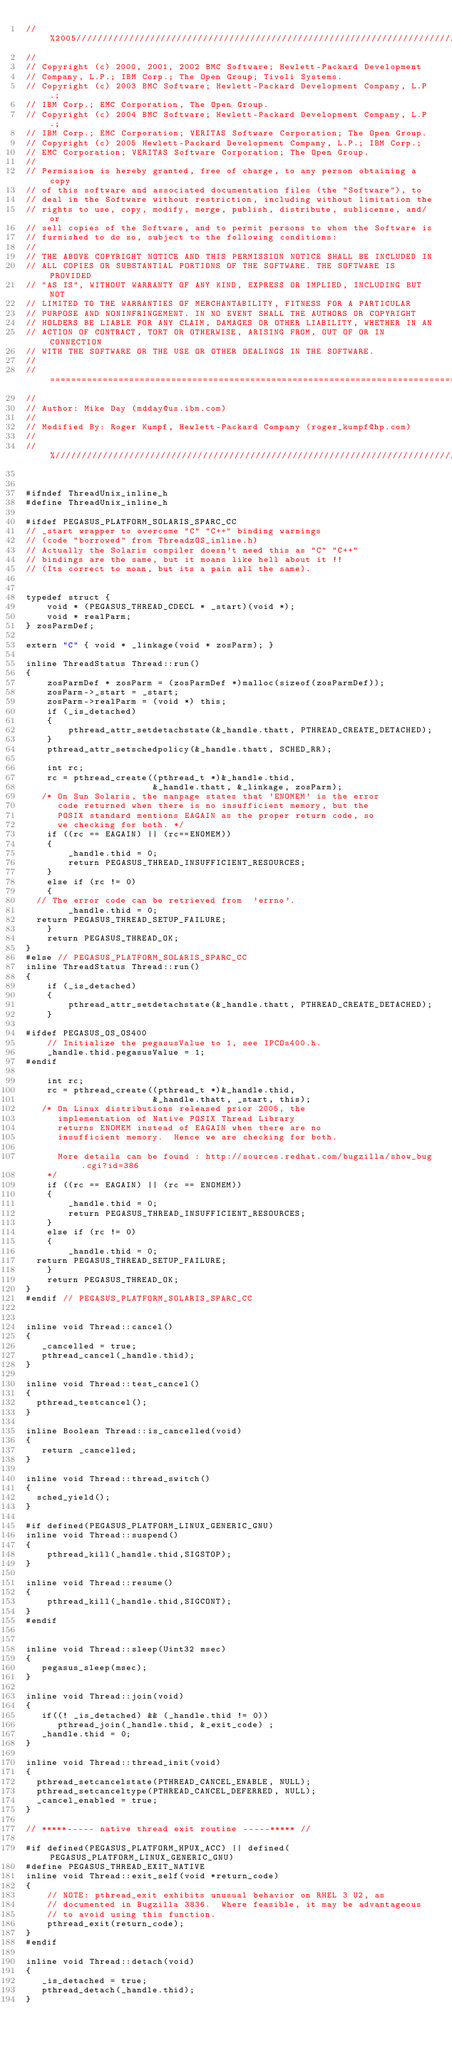Convert code to text. <code><loc_0><loc_0><loc_500><loc_500><_C_>//%2005////////////////////////////////////////////////////////////////////////
//
// Copyright (c) 2000, 2001, 2002 BMC Software; Hewlett-Packard Development
// Company, L.P.; IBM Corp.; The Open Group; Tivoli Systems.
// Copyright (c) 2003 BMC Software; Hewlett-Packard Development Company, L.P.;
// IBM Corp.; EMC Corporation, The Open Group.
// Copyright (c) 2004 BMC Software; Hewlett-Packard Development Company, L.P.;
// IBM Corp.; EMC Corporation; VERITAS Software Corporation; The Open Group.
// Copyright (c) 2005 Hewlett-Packard Development Company, L.P.; IBM Corp.;
// EMC Corporation; VERITAS Software Corporation; The Open Group.
//
// Permission is hereby granted, free of charge, to any person obtaining a copy
// of this software and associated documentation files (the "Software"), to
// deal in the Software without restriction, including without limitation the
// rights to use, copy, modify, merge, publish, distribute, sublicense, and/or
// sell copies of the Software, and to permit persons to whom the Software is
// furnished to do so, subject to the following conditions:
// 
// THE ABOVE COPYRIGHT NOTICE AND THIS PERMISSION NOTICE SHALL BE INCLUDED IN
// ALL COPIES OR SUBSTANTIAL PORTIONS OF THE SOFTWARE. THE SOFTWARE IS PROVIDED
// "AS IS", WITHOUT WARRANTY OF ANY KIND, EXPRESS OR IMPLIED, INCLUDING BUT NOT
// LIMITED TO THE WARRANTIES OF MERCHANTABILITY, FITNESS FOR A PARTICULAR
// PURPOSE AND NONINFRINGEMENT. IN NO EVENT SHALL THE AUTHORS OR COPYRIGHT
// HOLDERS BE LIABLE FOR ANY CLAIM, DAMAGES OR OTHER LIABILITY, WHETHER IN AN
// ACTION OF CONTRACT, TORT OR OTHERWISE, ARISING FROM, OUT OF OR IN CONNECTION
// WITH THE SOFTWARE OR THE USE OR OTHER DEALINGS IN THE SOFTWARE.
//
//==============================================================================
//
// Author: Mike Day (mdday@us.ibm.com)
//
// Modified By: Roger Kumpf, Hewlett-Packard Company (roger_kumpf@hp.com)
//
//%/////////////////////////////////////////////////////////////////////////////


#ifndef ThreadUnix_inline_h
#define ThreadUnix_inline_h

#ifdef PEGASUS_PLATFORM_SOLARIS_SPARC_CC
// _start wrapper to overcome "C" "C++" binding warnings
// (code "borrowed" from ThreadzOS_inline.h)
// Actually the Solaris compiler doesn't need this as "C" "C++"
// bindings are the same, but it moans like hell about it !!
// (Its correct to moan, but its a pain all the same).


typedef struct {                                   
    void * (PEGASUS_THREAD_CDECL * _start)(void *);
    void * realParm;                               
} zosParmDef;                                      

extern "C" { void * _linkage(void * zosParm); }
                                                   
inline ThreadStatus Thread::run()
{
    zosParmDef * zosParm = (zosParmDef *)malloc(sizeof(zosParmDef));
    zosParm->_start = _start;
    zosParm->realParm = (void *) this;
    if (_is_detached)
    {
        pthread_attr_setdetachstate(&_handle.thatt, PTHREAD_CREATE_DETACHED);
    }
    pthread_attr_setschedpolicy(&_handle.thatt, SCHED_RR);

    int rc;
    rc = pthread_create((pthread_t *)&_handle.thid,
                        &_handle.thatt, &_linkage, zosParm);
   /* On Sun Solaris, the manpage states that 'ENOMEM' is the error
      code returned when there is no insufficient memory, but the 
      POSIX standard mentions EAGAIN as the proper return code, so
      we checking for both. */ 
    if ((rc == EAGAIN) || (rc==ENOMEM))
    {
        _handle.thid = 0;
        return PEGASUS_THREAD_INSUFFICIENT_RESOURCES;
    }
    else if (rc != 0)
    {
	// The error code can be retrieved from  'errno'.
        _handle.thid = 0;
	return PEGASUS_THREAD_SETUP_FAILURE;
    }
    return PEGASUS_THREAD_OK;
}
#else // PEGASUS_PLATFORM_SOLARIS_SPARC_CC
inline ThreadStatus Thread::run()
{
    if (_is_detached)
    {
        pthread_attr_setdetachstate(&_handle.thatt, PTHREAD_CREATE_DETACHED);
    }

#ifdef PEGASUS_OS_OS400
    // Initialize the pegasusValue to 1, see IPCOs400.h.
    _handle.thid.pegasusValue = 1;  
#endif

    int rc;
    rc = pthread_create((pthread_t *)&_handle.thid,
                        &_handle.thatt, _start, this);
   /* On Linux distributions released prior 2005, the 
      implementation of Native POSIX Thread Library 
      returns ENOMEM instead of EAGAIN when there are no 
      insufficient memory.  Hence we are checking for both. 

      More details can be found : http://sources.redhat.com/bugzilla/show_bug.cgi?id=386
    */
    if ((rc == EAGAIN) || (rc == ENOMEM))
    {
        _handle.thid = 0;
        return PEGASUS_THREAD_INSUFFICIENT_RESOURCES;
    }
    else if (rc != 0)
    {
        _handle.thid = 0;
	return PEGASUS_THREAD_SETUP_FAILURE;
    }
    return PEGASUS_THREAD_OK;
}
#endif // PEGASUS_PLATFORM_SOLARIS_SPARC_CC


inline void Thread::cancel()
{
   _cancelled = true;
   pthread_cancel(_handle.thid);
}

inline void Thread::test_cancel()
{
  pthread_testcancel();
}

inline Boolean Thread::is_cancelled(void)
{
   return _cancelled;
}

inline void Thread::thread_switch()
{
  sched_yield();
}

#if defined(PEGASUS_PLATFORM_LINUX_GENERIC_GNU)
inline void Thread::suspend()
{
    pthread_kill(_handle.thid,SIGSTOP);
}

inline void Thread::resume()
{
    pthread_kill(_handle.thid,SIGCONT);
}
#endif


inline void Thread::sleep(Uint32 msec)
{
   pegasus_sleep(msec);
}

inline void Thread::join(void) 
{ 
   if((! _is_detached) && (_handle.thid != 0))
      pthread_join(_handle.thid, &_exit_code) ; 
   _handle.thid = 0;
}

inline void Thread::thread_init(void)
{
  pthread_setcancelstate(PTHREAD_CANCEL_ENABLE, NULL);
  pthread_setcanceltype(PTHREAD_CANCEL_DEFERRED, NULL);
  _cancel_enabled = true;
}

// *****----- native thread exit routine -----***** //

#if defined(PEGASUS_PLATFORM_HPUX_ACC) || defined(PEGASUS_PLATFORM_LINUX_GENERIC_GNU)
#define PEGASUS_THREAD_EXIT_NATIVE 
inline void Thread::exit_self(void *return_code)
{
    // NOTE: pthread_exit exhibits unusual behavior on RHEL 3 U2, as
    // documented in Bugzilla 3836.  Where feasible, it may be advantageous
    // to avoid using this function.
    pthread_exit(return_code);
}
#endif

inline void Thread::detach(void)
{
   _is_detached = true;
   pthread_detach(_handle.thid);
}
</code> 